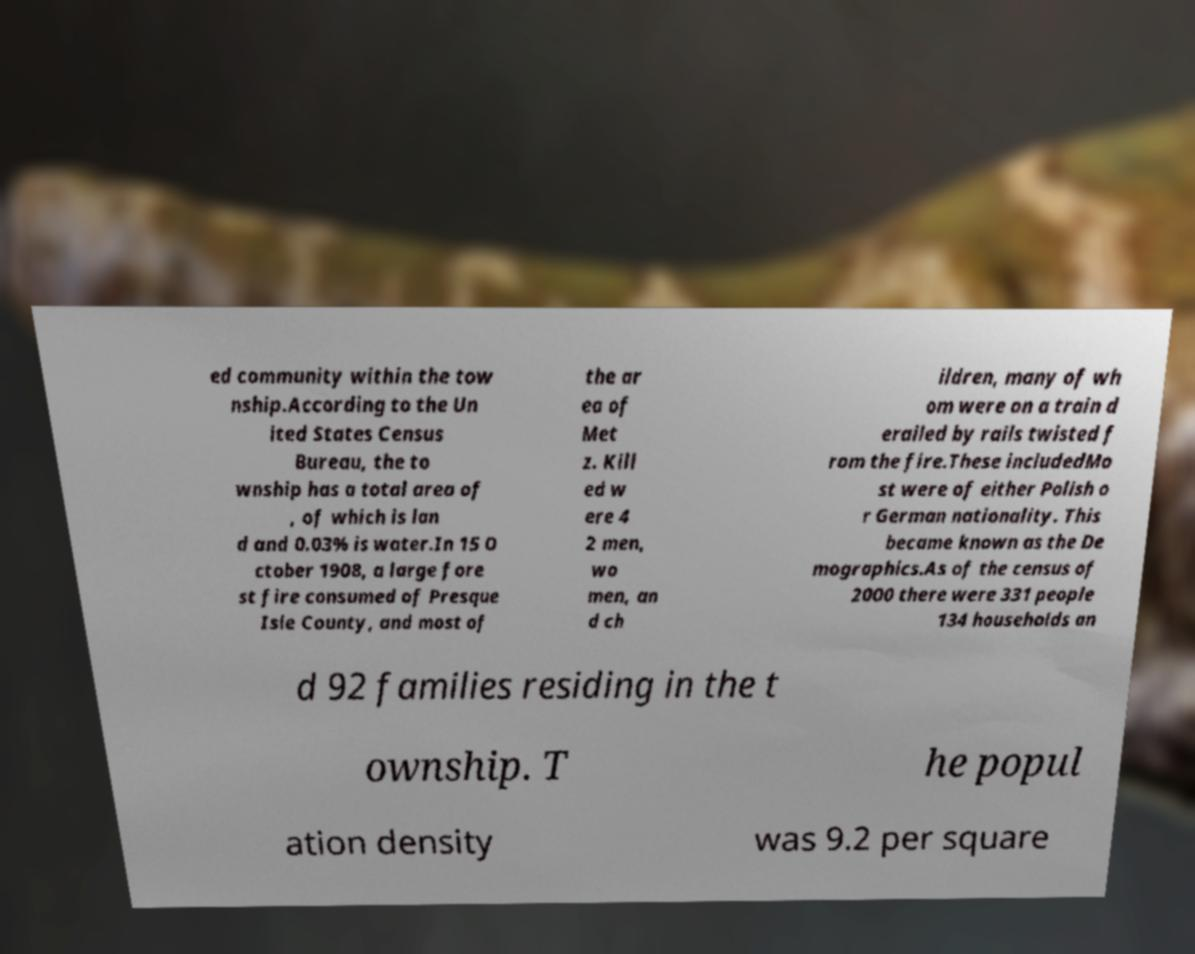Could you extract and type out the text from this image? ed community within the tow nship.According to the Un ited States Census Bureau, the to wnship has a total area of , of which is lan d and 0.03% is water.In 15 O ctober 1908, a large fore st fire consumed of Presque Isle County, and most of the ar ea of Met z. Kill ed w ere 4 2 men, wo men, an d ch ildren, many of wh om were on a train d erailed by rails twisted f rom the fire.These includedMo st were of either Polish o r German nationality. This became known as the De mographics.As of the census of 2000 there were 331 people 134 households an d 92 families residing in the t ownship. T he popul ation density was 9.2 per square 